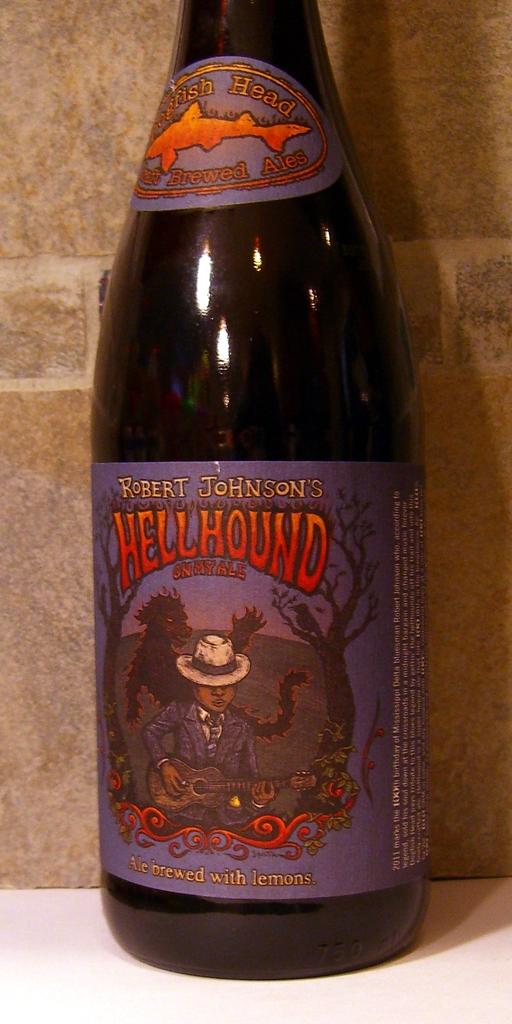What fruit is used in the brewing of this beer?
Your answer should be compact. Lemons. What is the name of the beer?
Make the answer very short. Hellhound. 